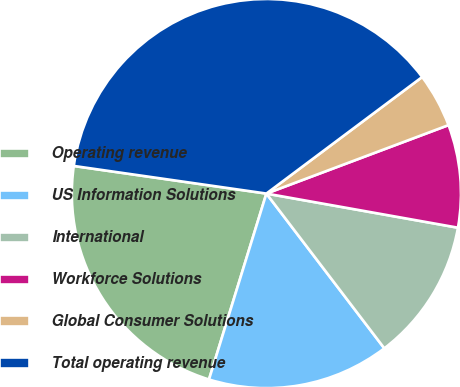<chart> <loc_0><loc_0><loc_500><loc_500><pie_chart><fcel>Operating revenue<fcel>US Information Solutions<fcel>International<fcel>Workforce Solutions<fcel>Global Consumer Solutions<fcel>Total operating revenue<nl><fcel>22.5%<fcel>15.13%<fcel>11.83%<fcel>8.53%<fcel>4.5%<fcel>37.51%<nl></chart> 